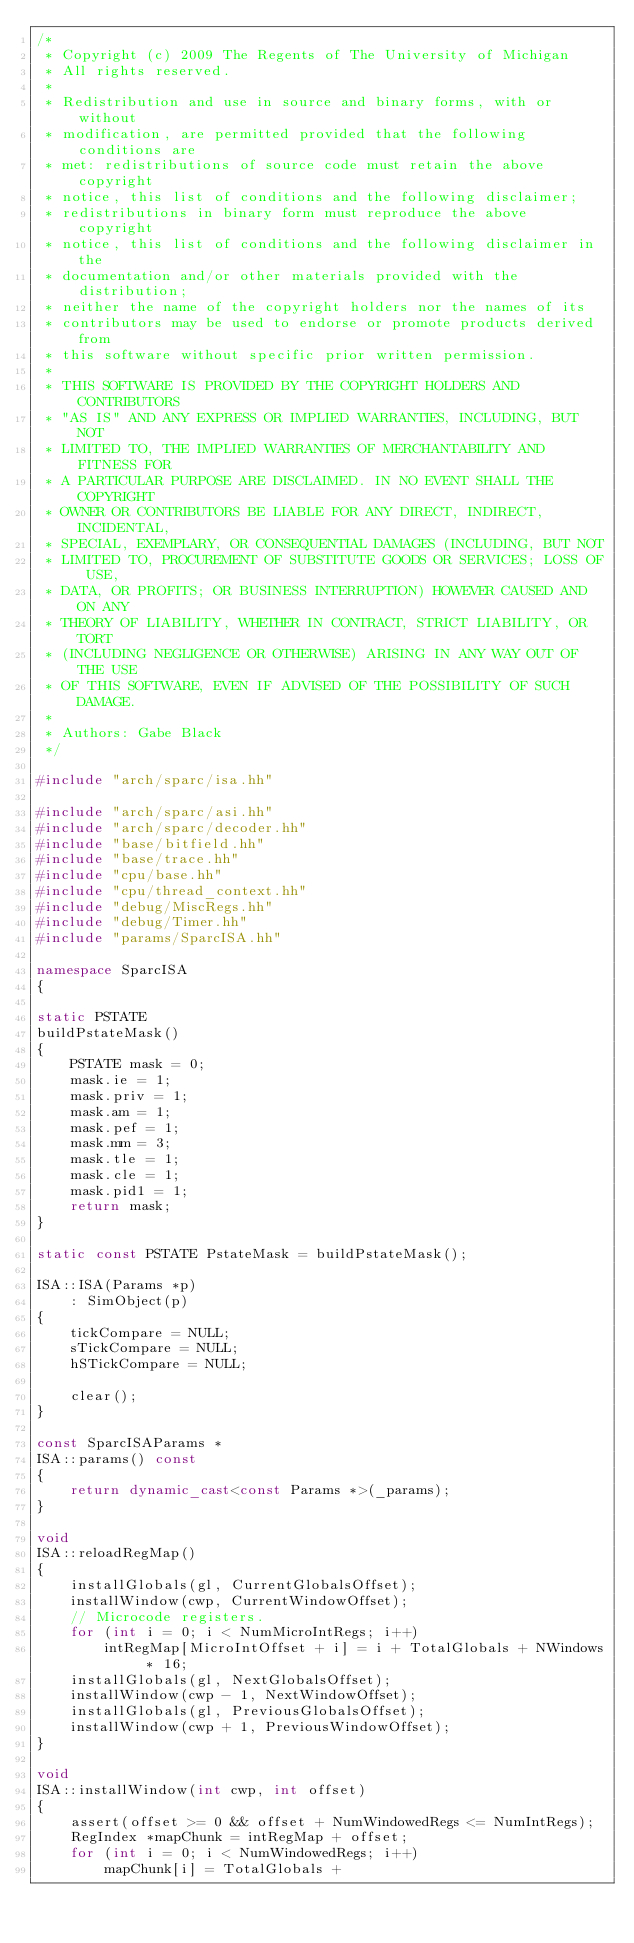Convert code to text. <code><loc_0><loc_0><loc_500><loc_500><_C++_>/*
 * Copyright (c) 2009 The Regents of The University of Michigan
 * All rights reserved.
 *
 * Redistribution and use in source and binary forms, with or without
 * modification, are permitted provided that the following conditions are
 * met: redistributions of source code must retain the above copyright
 * notice, this list of conditions and the following disclaimer;
 * redistributions in binary form must reproduce the above copyright
 * notice, this list of conditions and the following disclaimer in the
 * documentation and/or other materials provided with the distribution;
 * neither the name of the copyright holders nor the names of its
 * contributors may be used to endorse or promote products derived from
 * this software without specific prior written permission.
 *
 * THIS SOFTWARE IS PROVIDED BY THE COPYRIGHT HOLDERS AND CONTRIBUTORS
 * "AS IS" AND ANY EXPRESS OR IMPLIED WARRANTIES, INCLUDING, BUT NOT
 * LIMITED TO, THE IMPLIED WARRANTIES OF MERCHANTABILITY AND FITNESS FOR
 * A PARTICULAR PURPOSE ARE DISCLAIMED. IN NO EVENT SHALL THE COPYRIGHT
 * OWNER OR CONTRIBUTORS BE LIABLE FOR ANY DIRECT, INDIRECT, INCIDENTAL,
 * SPECIAL, EXEMPLARY, OR CONSEQUENTIAL DAMAGES (INCLUDING, BUT NOT
 * LIMITED TO, PROCUREMENT OF SUBSTITUTE GOODS OR SERVICES; LOSS OF USE,
 * DATA, OR PROFITS; OR BUSINESS INTERRUPTION) HOWEVER CAUSED AND ON ANY
 * THEORY OF LIABILITY, WHETHER IN CONTRACT, STRICT LIABILITY, OR TORT
 * (INCLUDING NEGLIGENCE OR OTHERWISE) ARISING IN ANY WAY OUT OF THE USE
 * OF THIS SOFTWARE, EVEN IF ADVISED OF THE POSSIBILITY OF SUCH DAMAGE.
 *
 * Authors: Gabe Black
 */

#include "arch/sparc/isa.hh"

#include "arch/sparc/asi.hh"
#include "arch/sparc/decoder.hh"
#include "base/bitfield.hh"
#include "base/trace.hh"
#include "cpu/base.hh"
#include "cpu/thread_context.hh"
#include "debug/MiscRegs.hh"
#include "debug/Timer.hh"
#include "params/SparcISA.hh"

namespace SparcISA
{

static PSTATE
buildPstateMask()
{
    PSTATE mask = 0;
    mask.ie = 1;
    mask.priv = 1;
    mask.am = 1;
    mask.pef = 1;
    mask.mm = 3;
    mask.tle = 1;
    mask.cle = 1;
    mask.pid1 = 1;
    return mask;
}

static const PSTATE PstateMask = buildPstateMask();

ISA::ISA(Params *p)
    : SimObject(p)
{
    tickCompare = NULL;
    sTickCompare = NULL;
    hSTickCompare = NULL;

    clear();
}

const SparcISAParams *
ISA::params() const
{
    return dynamic_cast<const Params *>(_params);
}

void
ISA::reloadRegMap()
{
    installGlobals(gl, CurrentGlobalsOffset);
    installWindow(cwp, CurrentWindowOffset);
    // Microcode registers.
    for (int i = 0; i < NumMicroIntRegs; i++)
        intRegMap[MicroIntOffset + i] = i + TotalGlobals + NWindows * 16;
    installGlobals(gl, NextGlobalsOffset);
    installWindow(cwp - 1, NextWindowOffset);
    installGlobals(gl, PreviousGlobalsOffset);
    installWindow(cwp + 1, PreviousWindowOffset);
}

void
ISA::installWindow(int cwp, int offset)
{
    assert(offset >= 0 && offset + NumWindowedRegs <= NumIntRegs);
    RegIndex *mapChunk = intRegMap + offset;
    for (int i = 0; i < NumWindowedRegs; i++)
        mapChunk[i] = TotalGlobals +</code> 